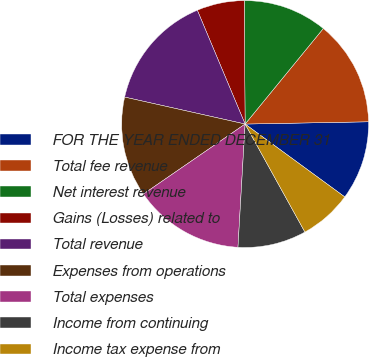Convert chart. <chart><loc_0><loc_0><loc_500><loc_500><pie_chart><fcel>FOR THE YEAR ENDED DECEMBER 31<fcel>Total fee revenue<fcel>Net interest revenue<fcel>Gains (Losses) related to<fcel>Total revenue<fcel>Expenses from operations<fcel>Total expenses<fcel>Income from continuing<fcel>Income tax expense from<nl><fcel>10.34%<fcel>13.79%<fcel>11.03%<fcel>6.21%<fcel>15.17%<fcel>13.1%<fcel>14.48%<fcel>8.97%<fcel>6.9%<nl></chart> 